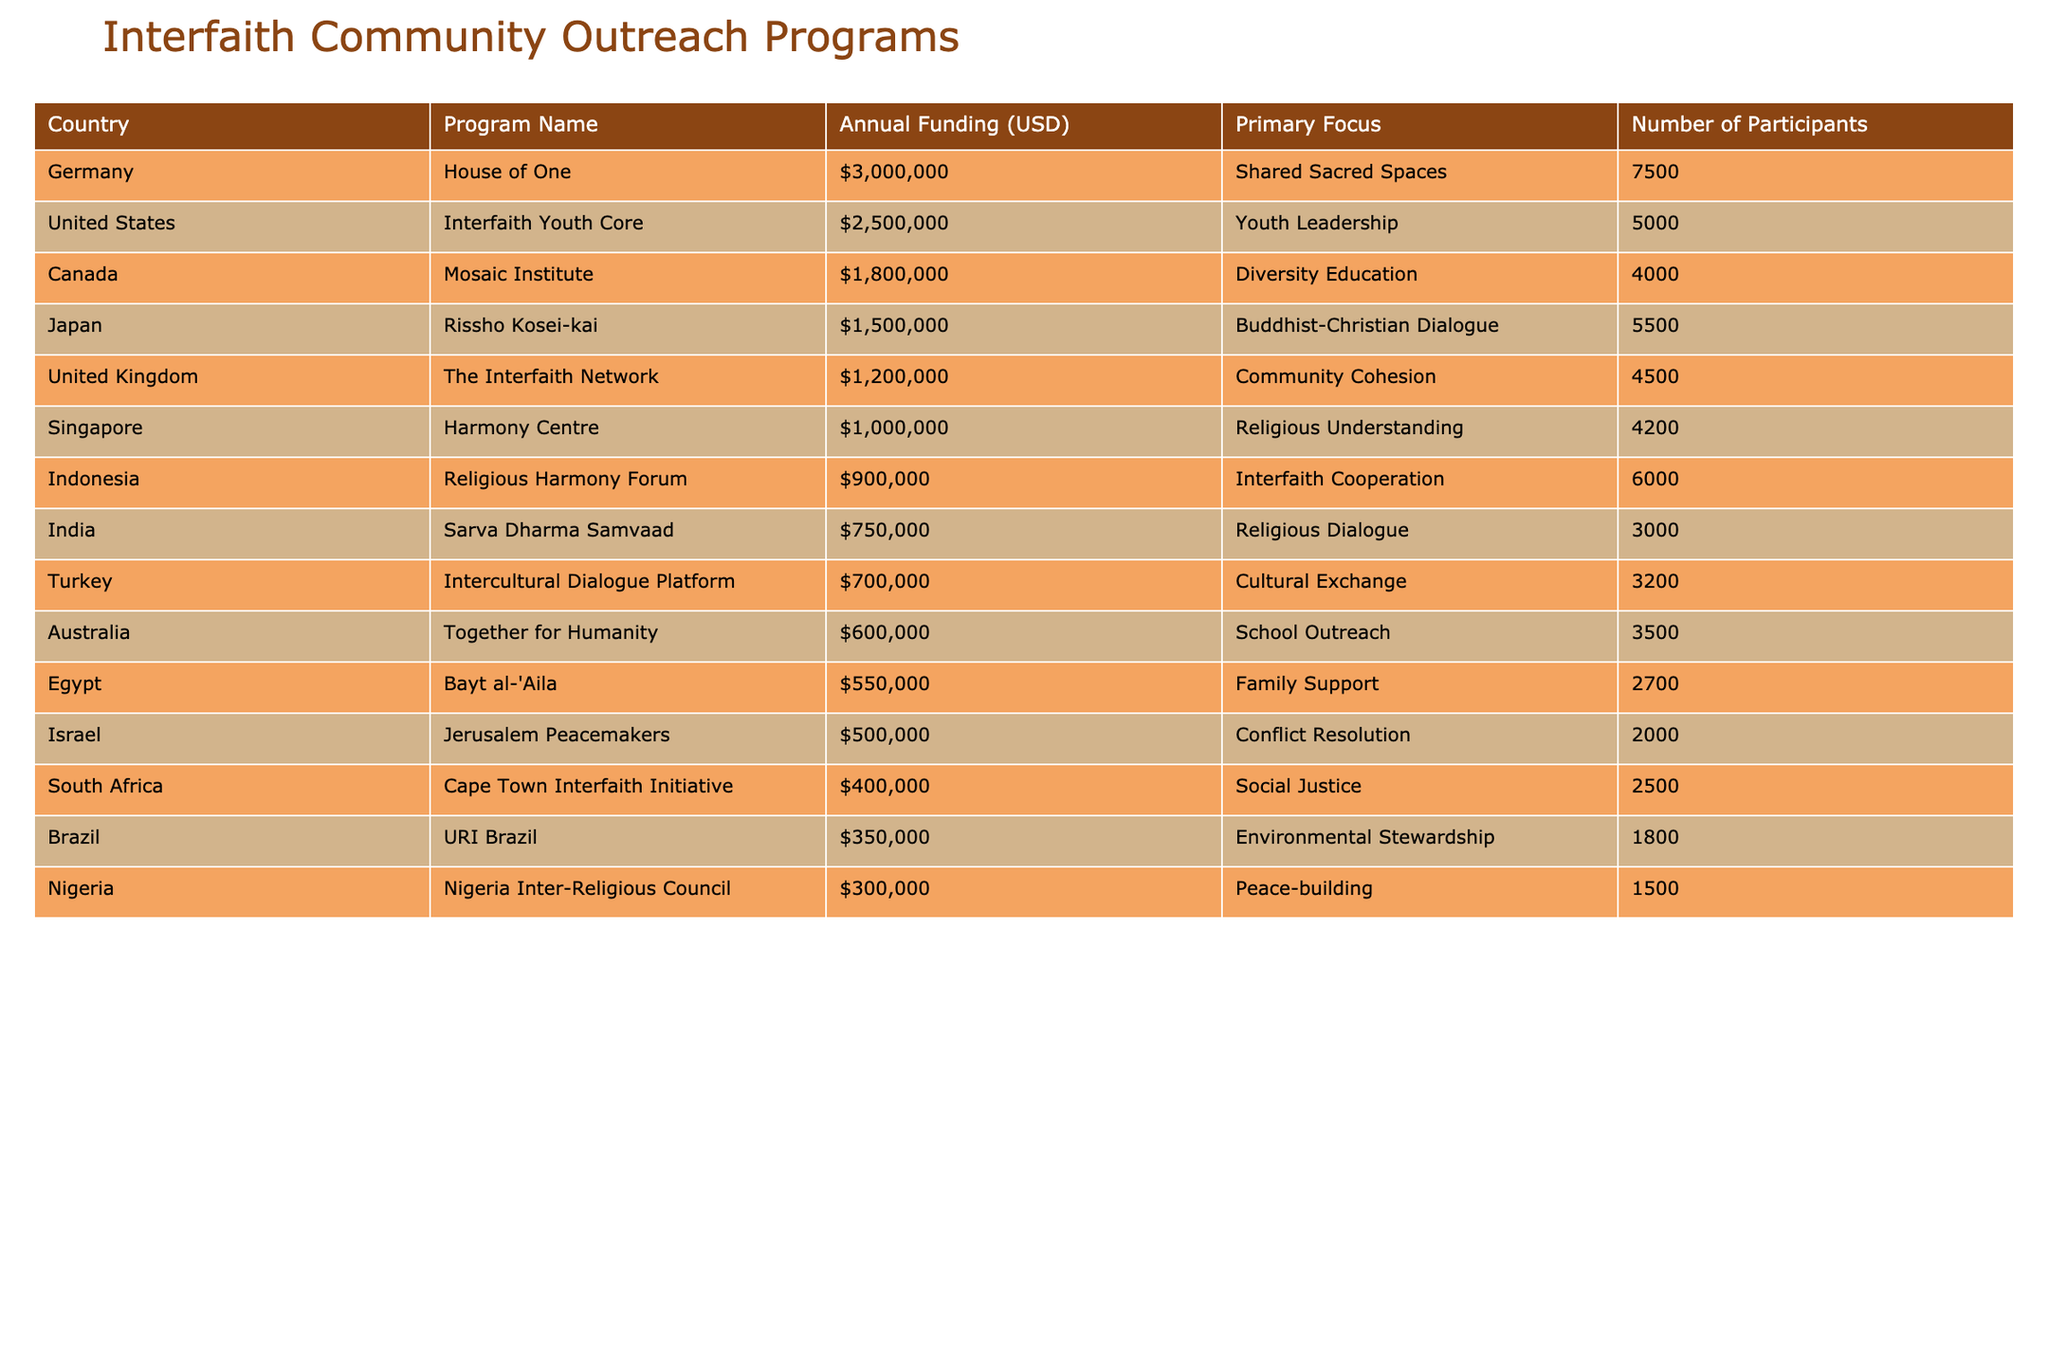What is the annual funding for the "House of One" program in Germany? The "House of One" program in Germany has an annual funding of $3,000,000 as per the table.
Answer: $3,000,000 Which country has the highest annual funding for interfaith community outreach programs? According to the table, Germany's "House of One" has the highest annual funding at $3,000,000.
Answer: Germany What is the primary focus of the program with the second highest funding? The second highest funding is for the "Interfaith Youth Core" in the United States, with a primary focus on Youth Leadership as indicated in the table.
Answer: Youth Leadership How many participants are there in the "Jerusalem Peacemakers" program in Israel? "Jerusalem Peacemakers" in Israel has 2,000 participants, which can be found directly in the table.
Answer: 2,000 Calculate the total annual funding for interfaith community outreach programs in India and Turkey combined. India's funding is $750,000 and Turkey's funding is $700,000. The total is $750,000 + $700,000 = $1,450,000.
Answer: $1,450,000 Is the funding for the "Interfaith Network" program in the United Kingdom greater than $1,500,000? The "Interfaith Network" program has an funding of $1,200,000, which is less than $1,500,000. Thus, the statement is false.
Answer: No What is the average number of participants across all programs listed in the table? The total number of participants can be calculated: 5,000 + 3,000 + 4,500 + 7,500 + 2,000 + 6,000 + 4,000 + 3,500 + 2,500 + 5,500 + 3,200 + 1,800 + 2,700 + 4,200 + 1,500 = 58,400. Dividing this by 15 (the number of programs) gives an average of approximately 3,893.33.
Answer: Approximately 3,893 Which program has the focus on "Environmental Stewardship"? The program with a focus on "Environmental Stewardship" is "URI Brazil" in Brazil, as clearly stated in the table.
Answer: URI Brazil List all programs that have an annual funding of less than $1,000,000. The programs with funding less than $1,000,000 are: "Sarva Dharma Samvaad," "Jerusalem Peacemakers," "Cape Town Interfaith Initiative," "Together for Humanity," "Brazil URI," and "Nigeria Inter-Religious Council." By reviewing the funding amounts, these programs fit this criterion.
Answer: Six programs What is the difference in annual funding between the "Mosaic Institute" in Canada and the "Cape Town Interfaith Initiative" in South Africa? The "Mosaic Institute" has annual funding of $1,800,000 while the "Cape Town Interfaith Initiative" has $400,000. The difference is $1,800,000 - $400,000 = $1,400,000.
Answer: $1,400,000 